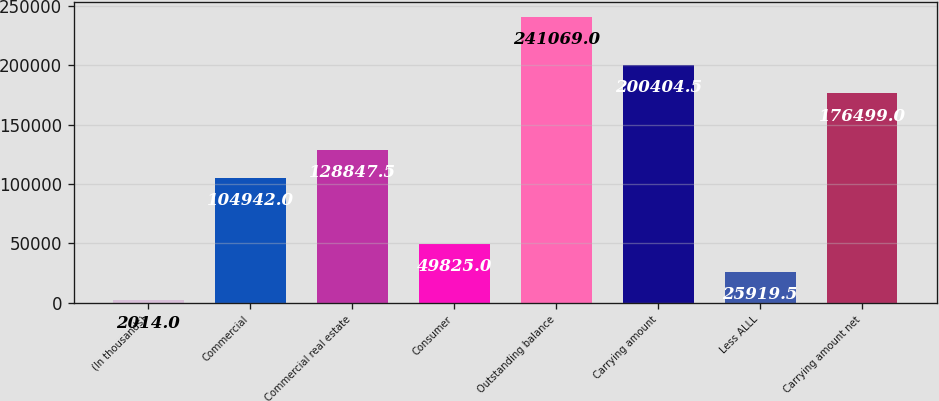Convert chart. <chart><loc_0><loc_0><loc_500><loc_500><bar_chart><fcel>(In thousands)<fcel>Commercial<fcel>Commercial real estate<fcel>Consumer<fcel>Outstanding balance<fcel>Carrying amount<fcel>Less ALLL<fcel>Carrying amount net<nl><fcel>2014<fcel>104942<fcel>128848<fcel>49825<fcel>241069<fcel>200404<fcel>25919.5<fcel>176499<nl></chart> 